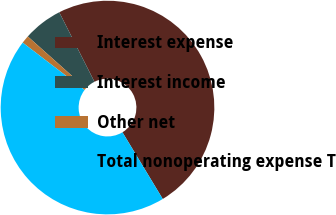Convert chart to OTSL. <chart><loc_0><loc_0><loc_500><loc_500><pie_chart><fcel>Interest expense<fcel>Interest income<fcel>Other net<fcel>Total nonoperating expense T<nl><fcel>48.81%<fcel>5.95%<fcel>1.19%<fcel>44.05%<nl></chart> 